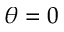Convert formula to latex. <formula><loc_0><loc_0><loc_500><loc_500>\theta = 0</formula> 